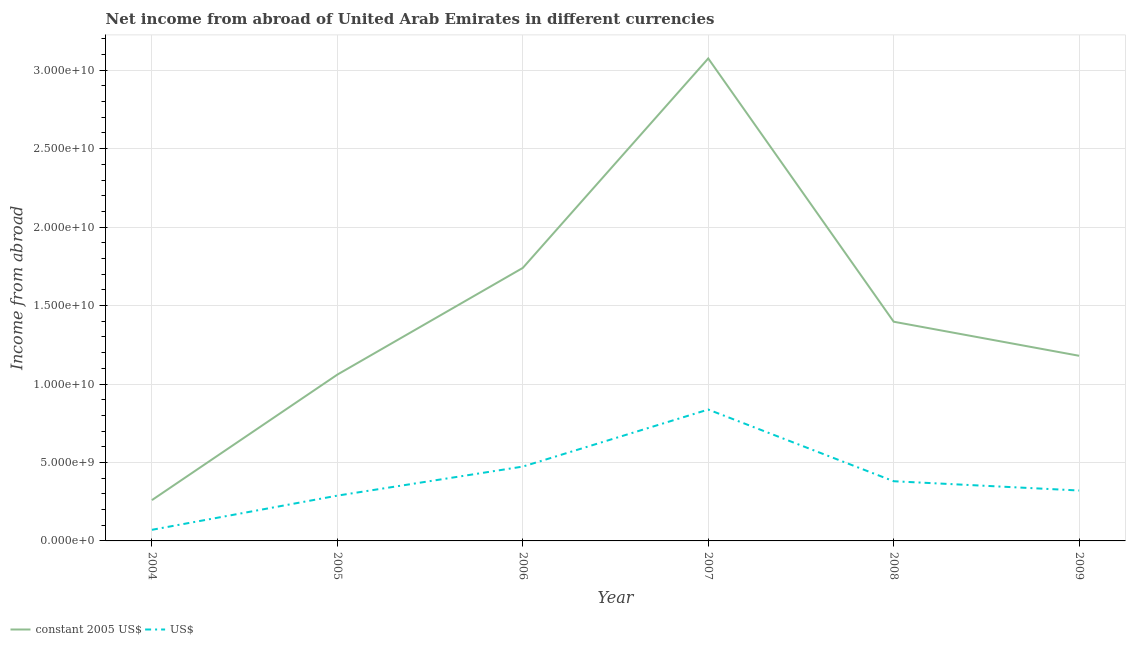How many different coloured lines are there?
Give a very brief answer. 2. Does the line corresponding to income from abroad in constant 2005 us$ intersect with the line corresponding to income from abroad in us$?
Provide a short and direct response. No. Is the number of lines equal to the number of legend labels?
Your answer should be very brief. Yes. What is the income from abroad in us$ in 2007?
Your answer should be compact. 8.37e+09. Across all years, what is the maximum income from abroad in constant 2005 us$?
Ensure brevity in your answer.  3.08e+1. Across all years, what is the minimum income from abroad in constant 2005 us$?
Provide a short and direct response. 2.60e+09. In which year was the income from abroad in constant 2005 us$ maximum?
Provide a short and direct response. 2007. What is the total income from abroad in constant 2005 us$ in the graph?
Your response must be concise. 8.71e+1. What is the difference between the income from abroad in constant 2005 us$ in 2004 and that in 2006?
Provide a short and direct response. -1.48e+1. What is the difference between the income from abroad in us$ in 2004 and the income from abroad in constant 2005 us$ in 2006?
Give a very brief answer. -1.67e+1. What is the average income from abroad in constant 2005 us$ per year?
Keep it short and to the point. 1.45e+1. In the year 2005, what is the difference between the income from abroad in us$ and income from abroad in constant 2005 us$?
Offer a terse response. -7.71e+09. In how many years, is the income from abroad in us$ greater than 12000000000 units?
Make the answer very short. 0. What is the ratio of the income from abroad in us$ in 2005 to that in 2009?
Provide a succinct answer. 0.9. What is the difference between the highest and the second highest income from abroad in us$?
Your answer should be very brief. 3.64e+09. What is the difference between the highest and the lowest income from abroad in us$?
Provide a short and direct response. 7.67e+09. In how many years, is the income from abroad in us$ greater than the average income from abroad in us$ taken over all years?
Keep it short and to the point. 2. Is the sum of the income from abroad in us$ in 2004 and 2008 greater than the maximum income from abroad in constant 2005 us$ across all years?
Offer a terse response. No. Is the income from abroad in us$ strictly greater than the income from abroad in constant 2005 us$ over the years?
Your answer should be very brief. No. How many lines are there?
Make the answer very short. 2. How many years are there in the graph?
Offer a terse response. 6. Are the values on the major ticks of Y-axis written in scientific E-notation?
Make the answer very short. Yes. How many legend labels are there?
Keep it short and to the point. 2. What is the title of the graph?
Offer a very short reply. Net income from abroad of United Arab Emirates in different currencies. What is the label or title of the X-axis?
Offer a very short reply. Year. What is the label or title of the Y-axis?
Your response must be concise. Income from abroad. What is the Income from abroad of constant 2005 US$ in 2004?
Provide a succinct answer. 2.60e+09. What is the Income from abroad of US$ in 2004?
Provide a short and direct response. 7.08e+08. What is the Income from abroad in constant 2005 US$ in 2005?
Give a very brief answer. 1.06e+1. What is the Income from abroad of US$ in 2005?
Provide a short and direct response. 2.89e+09. What is the Income from abroad in constant 2005 US$ in 2006?
Keep it short and to the point. 1.74e+1. What is the Income from abroad of US$ in 2006?
Your response must be concise. 4.74e+09. What is the Income from abroad of constant 2005 US$ in 2007?
Make the answer very short. 3.08e+1. What is the Income from abroad of US$ in 2007?
Provide a short and direct response. 8.37e+09. What is the Income from abroad of constant 2005 US$ in 2008?
Provide a short and direct response. 1.40e+1. What is the Income from abroad of US$ in 2008?
Your answer should be compact. 3.80e+09. What is the Income from abroad of constant 2005 US$ in 2009?
Your answer should be compact. 1.18e+1. What is the Income from abroad in US$ in 2009?
Your answer should be very brief. 3.21e+09. Across all years, what is the maximum Income from abroad in constant 2005 US$?
Provide a short and direct response. 3.08e+1. Across all years, what is the maximum Income from abroad in US$?
Your answer should be compact. 8.37e+09. Across all years, what is the minimum Income from abroad of constant 2005 US$?
Ensure brevity in your answer.  2.60e+09. Across all years, what is the minimum Income from abroad of US$?
Give a very brief answer. 7.08e+08. What is the total Income from abroad of constant 2005 US$ in the graph?
Your answer should be very brief. 8.71e+1. What is the total Income from abroad of US$ in the graph?
Your response must be concise. 2.37e+1. What is the difference between the Income from abroad of constant 2005 US$ in 2004 and that in 2005?
Make the answer very short. -8.00e+09. What is the difference between the Income from abroad of US$ in 2004 and that in 2005?
Offer a very short reply. -2.18e+09. What is the difference between the Income from abroad in constant 2005 US$ in 2004 and that in 2006?
Ensure brevity in your answer.  -1.48e+1. What is the difference between the Income from abroad of US$ in 2004 and that in 2006?
Offer a very short reply. -4.03e+09. What is the difference between the Income from abroad of constant 2005 US$ in 2004 and that in 2007?
Offer a terse response. -2.82e+1. What is the difference between the Income from abroad in US$ in 2004 and that in 2007?
Give a very brief answer. -7.67e+09. What is the difference between the Income from abroad of constant 2005 US$ in 2004 and that in 2008?
Your answer should be compact. -1.14e+1. What is the difference between the Income from abroad in US$ in 2004 and that in 2008?
Make the answer very short. -3.10e+09. What is the difference between the Income from abroad in constant 2005 US$ in 2004 and that in 2009?
Give a very brief answer. -9.20e+09. What is the difference between the Income from abroad in US$ in 2004 and that in 2009?
Ensure brevity in your answer.  -2.51e+09. What is the difference between the Income from abroad of constant 2005 US$ in 2005 and that in 2006?
Offer a terse response. -6.80e+09. What is the difference between the Income from abroad of US$ in 2005 and that in 2006?
Offer a terse response. -1.85e+09. What is the difference between the Income from abroad in constant 2005 US$ in 2005 and that in 2007?
Keep it short and to the point. -2.02e+1. What is the difference between the Income from abroad of US$ in 2005 and that in 2007?
Provide a short and direct response. -5.49e+09. What is the difference between the Income from abroad in constant 2005 US$ in 2005 and that in 2008?
Keep it short and to the point. -3.37e+09. What is the difference between the Income from abroad in US$ in 2005 and that in 2008?
Make the answer very short. -9.18e+08. What is the difference between the Income from abroad of constant 2005 US$ in 2005 and that in 2009?
Your response must be concise. -1.20e+09. What is the difference between the Income from abroad of US$ in 2005 and that in 2009?
Offer a very short reply. -3.27e+08. What is the difference between the Income from abroad of constant 2005 US$ in 2006 and that in 2007?
Your response must be concise. -1.34e+1. What is the difference between the Income from abroad of US$ in 2006 and that in 2007?
Provide a short and direct response. -3.64e+09. What is the difference between the Income from abroad in constant 2005 US$ in 2006 and that in 2008?
Offer a terse response. 3.43e+09. What is the difference between the Income from abroad in US$ in 2006 and that in 2008?
Ensure brevity in your answer.  9.34e+08. What is the difference between the Income from abroad in constant 2005 US$ in 2006 and that in 2009?
Offer a terse response. 5.60e+09. What is the difference between the Income from abroad of US$ in 2006 and that in 2009?
Offer a terse response. 1.52e+09. What is the difference between the Income from abroad of constant 2005 US$ in 2007 and that in 2008?
Keep it short and to the point. 1.68e+1. What is the difference between the Income from abroad in US$ in 2007 and that in 2008?
Provide a short and direct response. 4.57e+09. What is the difference between the Income from abroad in constant 2005 US$ in 2007 and that in 2009?
Keep it short and to the point. 1.90e+1. What is the difference between the Income from abroad in US$ in 2007 and that in 2009?
Provide a short and direct response. 5.16e+09. What is the difference between the Income from abroad in constant 2005 US$ in 2008 and that in 2009?
Provide a succinct answer. 2.17e+09. What is the difference between the Income from abroad in US$ in 2008 and that in 2009?
Your answer should be compact. 5.91e+08. What is the difference between the Income from abroad of constant 2005 US$ in 2004 and the Income from abroad of US$ in 2005?
Ensure brevity in your answer.  -2.86e+08. What is the difference between the Income from abroad of constant 2005 US$ in 2004 and the Income from abroad of US$ in 2006?
Give a very brief answer. -2.14e+09. What is the difference between the Income from abroad of constant 2005 US$ in 2004 and the Income from abroad of US$ in 2007?
Your answer should be compact. -5.77e+09. What is the difference between the Income from abroad in constant 2005 US$ in 2004 and the Income from abroad in US$ in 2008?
Give a very brief answer. -1.20e+09. What is the difference between the Income from abroad of constant 2005 US$ in 2004 and the Income from abroad of US$ in 2009?
Give a very brief answer. -6.13e+08. What is the difference between the Income from abroad in constant 2005 US$ in 2005 and the Income from abroad in US$ in 2006?
Your answer should be compact. 5.86e+09. What is the difference between the Income from abroad of constant 2005 US$ in 2005 and the Income from abroad of US$ in 2007?
Keep it short and to the point. 2.23e+09. What is the difference between the Income from abroad in constant 2005 US$ in 2005 and the Income from abroad in US$ in 2008?
Offer a very short reply. 6.80e+09. What is the difference between the Income from abroad of constant 2005 US$ in 2005 and the Income from abroad of US$ in 2009?
Ensure brevity in your answer.  7.39e+09. What is the difference between the Income from abroad in constant 2005 US$ in 2006 and the Income from abroad in US$ in 2007?
Provide a short and direct response. 9.03e+09. What is the difference between the Income from abroad of constant 2005 US$ in 2006 and the Income from abroad of US$ in 2008?
Provide a succinct answer. 1.36e+1. What is the difference between the Income from abroad in constant 2005 US$ in 2006 and the Income from abroad in US$ in 2009?
Your answer should be very brief. 1.42e+1. What is the difference between the Income from abroad in constant 2005 US$ in 2007 and the Income from abroad in US$ in 2008?
Offer a terse response. 2.69e+1. What is the difference between the Income from abroad in constant 2005 US$ in 2007 and the Income from abroad in US$ in 2009?
Offer a terse response. 2.75e+1. What is the difference between the Income from abroad in constant 2005 US$ in 2008 and the Income from abroad in US$ in 2009?
Provide a short and direct response. 1.08e+1. What is the average Income from abroad of constant 2005 US$ per year?
Give a very brief answer. 1.45e+1. What is the average Income from abroad in US$ per year?
Your answer should be very brief. 3.95e+09. In the year 2004, what is the difference between the Income from abroad of constant 2005 US$ and Income from abroad of US$?
Your answer should be compact. 1.89e+09. In the year 2005, what is the difference between the Income from abroad of constant 2005 US$ and Income from abroad of US$?
Keep it short and to the point. 7.71e+09. In the year 2006, what is the difference between the Income from abroad in constant 2005 US$ and Income from abroad in US$?
Provide a short and direct response. 1.27e+1. In the year 2007, what is the difference between the Income from abroad of constant 2005 US$ and Income from abroad of US$?
Provide a succinct answer. 2.24e+1. In the year 2008, what is the difference between the Income from abroad in constant 2005 US$ and Income from abroad in US$?
Give a very brief answer. 1.02e+1. In the year 2009, what is the difference between the Income from abroad of constant 2005 US$ and Income from abroad of US$?
Your answer should be very brief. 8.59e+09. What is the ratio of the Income from abroad of constant 2005 US$ in 2004 to that in 2005?
Provide a succinct answer. 0.25. What is the ratio of the Income from abroad in US$ in 2004 to that in 2005?
Your response must be concise. 0.25. What is the ratio of the Income from abroad in constant 2005 US$ in 2004 to that in 2006?
Give a very brief answer. 0.15. What is the ratio of the Income from abroad of US$ in 2004 to that in 2006?
Your response must be concise. 0.15. What is the ratio of the Income from abroad in constant 2005 US$ in 2004 to that in 2007?
Offer a very short reply. 0.08. What is the ratio of the Income from abroad in US$ in 2004 to that in 2007?
Give a very brief answer. 0.08. What is the ratio of the Income from abroad in constant 2005 US$ in 2004 to that in 2008?
Offer a very short reply. 0.19. What is the ratio of the Income from abroad of US$ in 2004 to that in 2008?
Your answer should be very brief. 0.19. What is the ratio of the Income from abroad of constant 2005 US$ in 2004 to that in 2009?
Provide a succinct answer. 0.22. What is the ratio of the Income from abroad of US$ in 2004 to that in 2009?
Your answer should be very brief. 0.22. What is the ratio of the Income from abroad in constant 2005 US$ in 2005 to that in 2006?
Your response must be concise. 0.61. What is the ratio of the Income from abroad of US$ in 2005 to that in 2006?
Make the answer very short. 0.61. What is the ratio of the Income from abroad of constant 2005 US$ in 2005 to that in 2007?
Offer a very short reply. 0.34. What is the ratio of the Income from abroad of US$ in 2005 to that in 2007?
Provide a short and direct response. 0.34. What is the ratio of the Income from abroad in constant 2005 US$ in 2005 to that in 2008?
Your answer should be very brief. 0.76. What is the ratio of the Income from abroad of US$ in 2005 to that in 2008?
Your response must be concise. 0.76. What is the ratio of the Income from abroad of constant 2005 US$ in 2005 to that in 2009?
Your answer should be very brief. 0.9. What is the ratio of the Income from abroad of US$ in 2005 to that in 2009?
Provide a short and direct response. 0.9. What is the ratio of the Income from abroad of constant 2005 US$ in 2006 to that in 2007?
Provide a short and direct response. 0.57. What is the ratio of the Income from abroad in US$ in 2006 to that in 2007?
Your response must be concise. 0.57. What is the ratio of the Income from abroad in constant 2005 US$ in 2006 to that in 2008?
Your answer should be compact. 1.25. What is the ratio of the Income from abroad in US$ in 2006 to that in 2008?
Your answer should be very brief. 1.25. What is the ratio of the Income from abroad of constant 2005 US$ in 2006 to that in 2009?
Your answer should be compact. 1.47. What is the ratio of the Income from abroad of US$ in 2006 to that in 2009?
Your answer should be compact. 1.47. What is the ratio of the Income from abroad in constant 2005 US$ in 2007 to that in 2008?
Provide a short and direct response. 2.2. What is the ratio of the Income from abroad in US$ in 2007 to that in 2008?
Your response must be concise. 2.2. What is the ratio of the Income from abroad of constant 2005 US$ in 2007 to that in 2009?
Your response must be concise. 2.61. What is the ratio of the Income from abroad in US$ in 2007 to that in 2009?
Offer a very short reply. 2.61. What is the ratio of the Income from abroad of constant 2005 US$ in 2008 to that in 2009?
Offer a terse response. 1.18. What is the ratio of the Income from abroad in US$ in 2008 to that in 2009?
Give a very brief answer. 1.18. What is the difference between the highest and the second highest Income from abroad of constant 2005 US$?
Give a very brief answer. 1.34e+1. What is the difference between the highest and the second highest Income from abroad in US$?
Your response must be concise. 3.64e+09. What is the difference between the highest and the lowest Income from abroad of constant 2005 US$?
Provide a succinct answer. 2.82e+1. What is the difference between the highest and the lowest Income from abroad of US$?
Your response must be concise. 7.67e+09. 